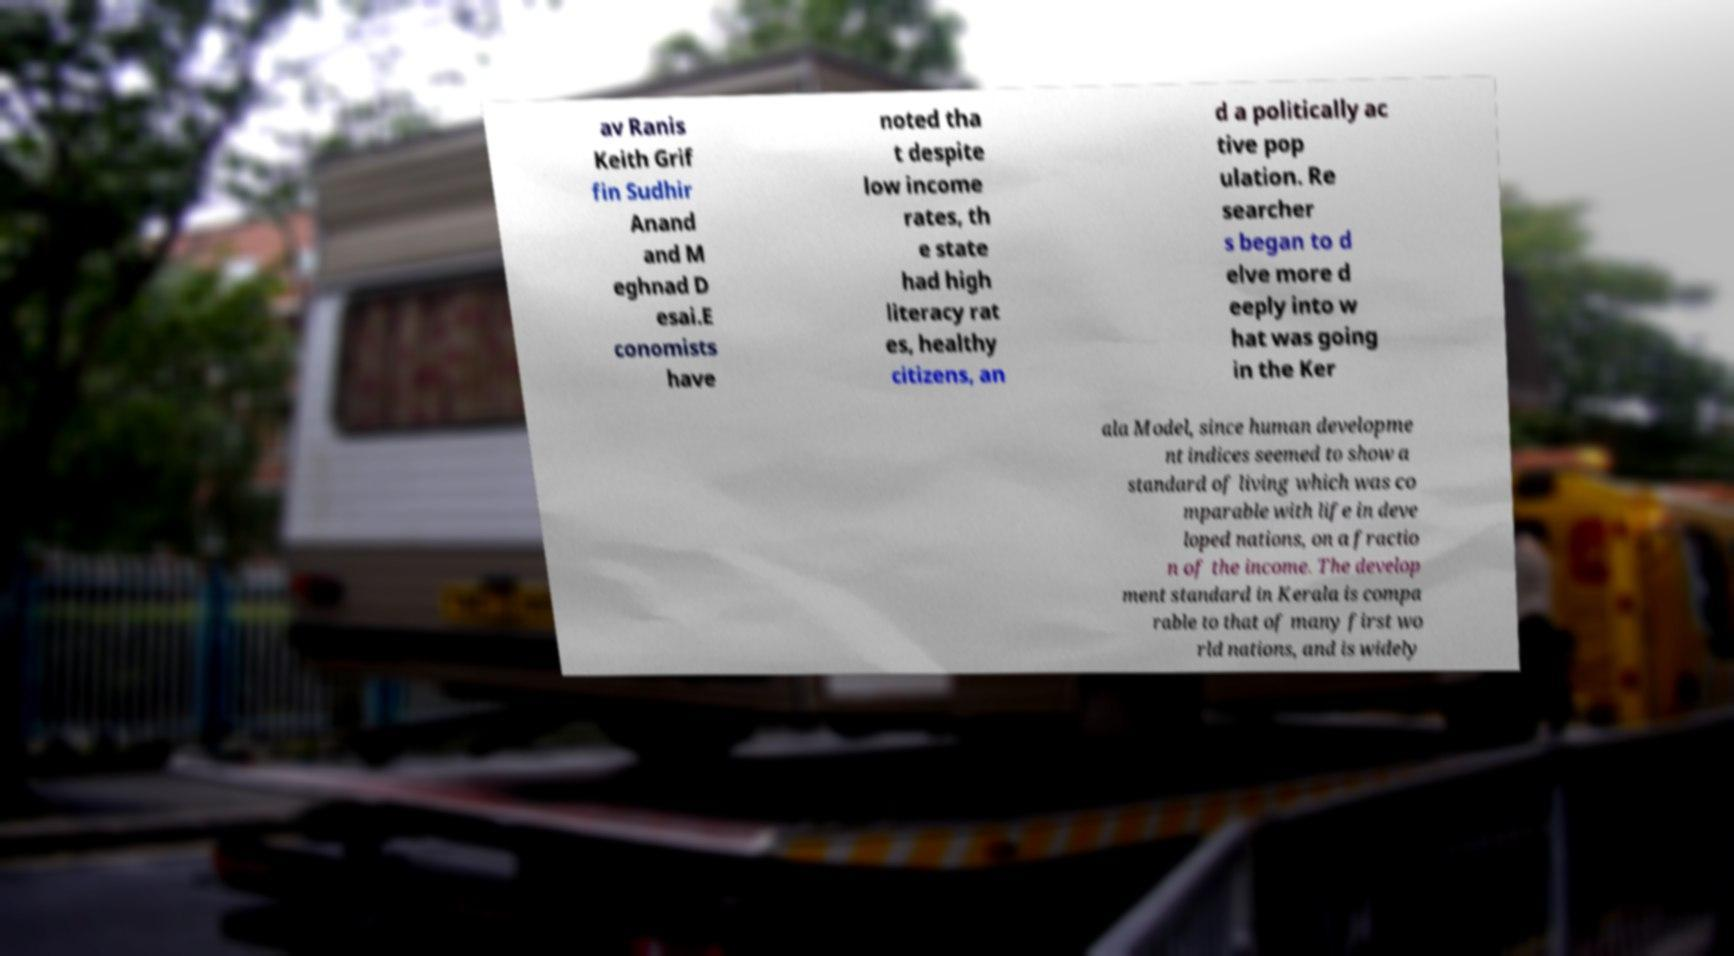Could you assist in decoding the text presented in this image and type it out clearly? av Ranis Keith Grif fin Sudhir Anand and M eghnad D esai.E conomists have noted tha t despite low income rates, th e state had high literacy rat es, healthy citizens, an d a politically ac tive pop ulation. Re searcher s began to d elve more d eeply into w hat was going in the Ker ala Model, since human developme nt indices seemed to show a standard of living which was co mparable with life in deve loped nations, on a fractio n of the income. The develop ment standard in Kerala is compa rable to that of many first wo rld nations, and is widely 